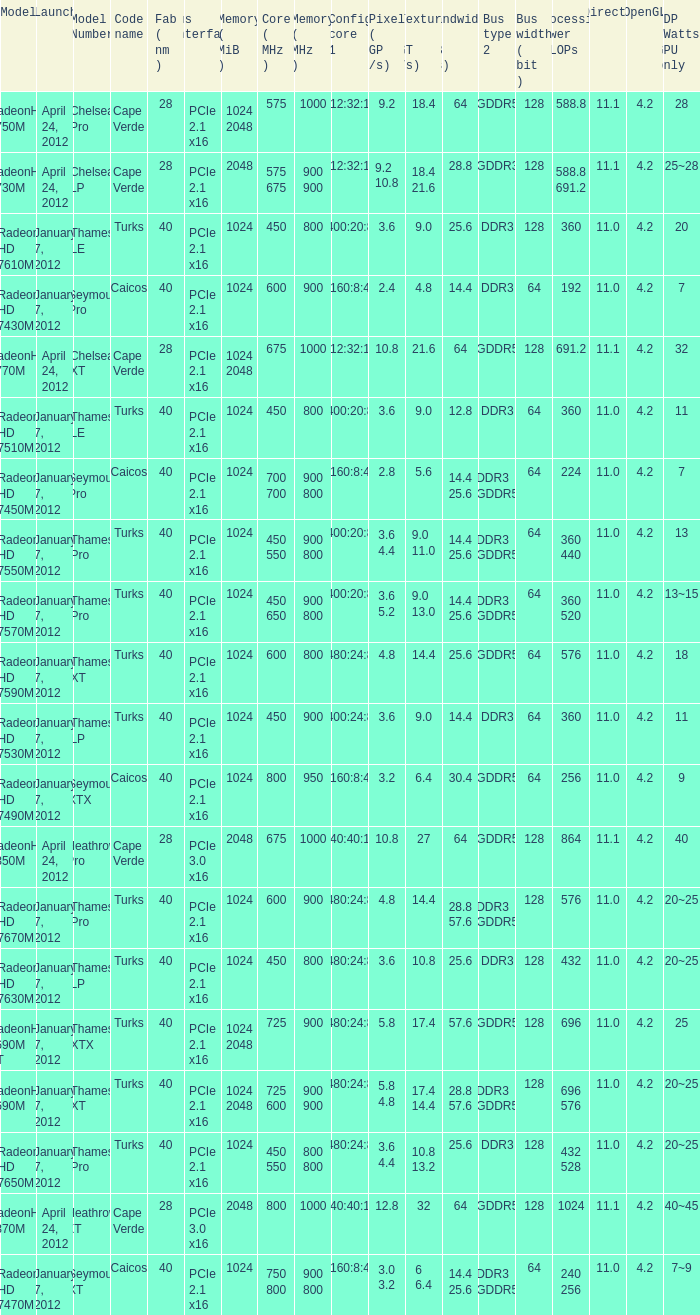What was the model's DirectX if it has a Core of 700 700 mhz? 11.0. 